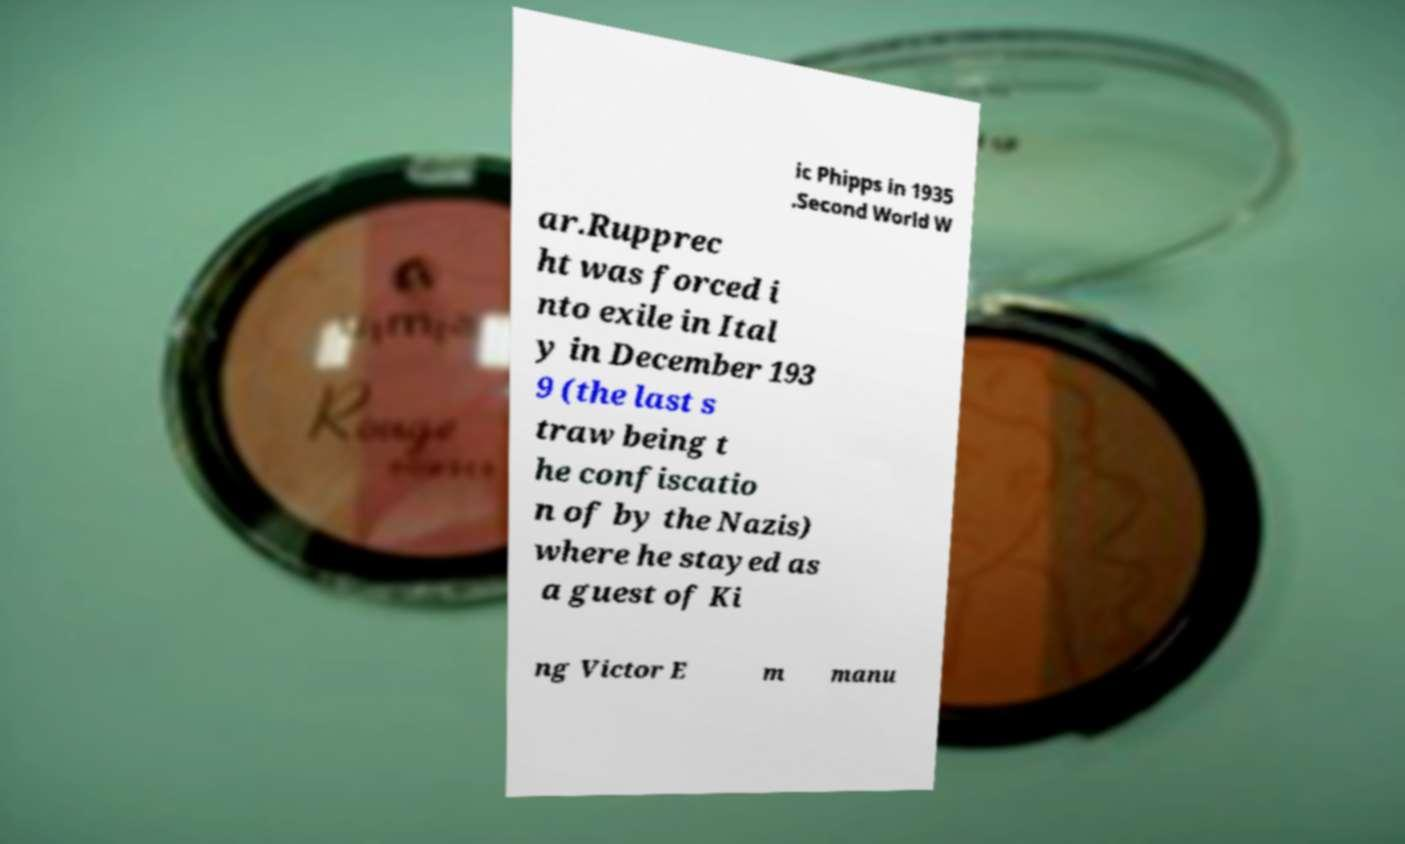Can you accurately transcribe the text from the provided image for me? ic Phipps in 1935 .Second World W ar.Rupprec ht was forced i nto exile in Ital y in December 193 9 (the last s traw being t he confiscatio n of by the Nazis) where he stayed as a guest of Ki ng Victor E m manu 